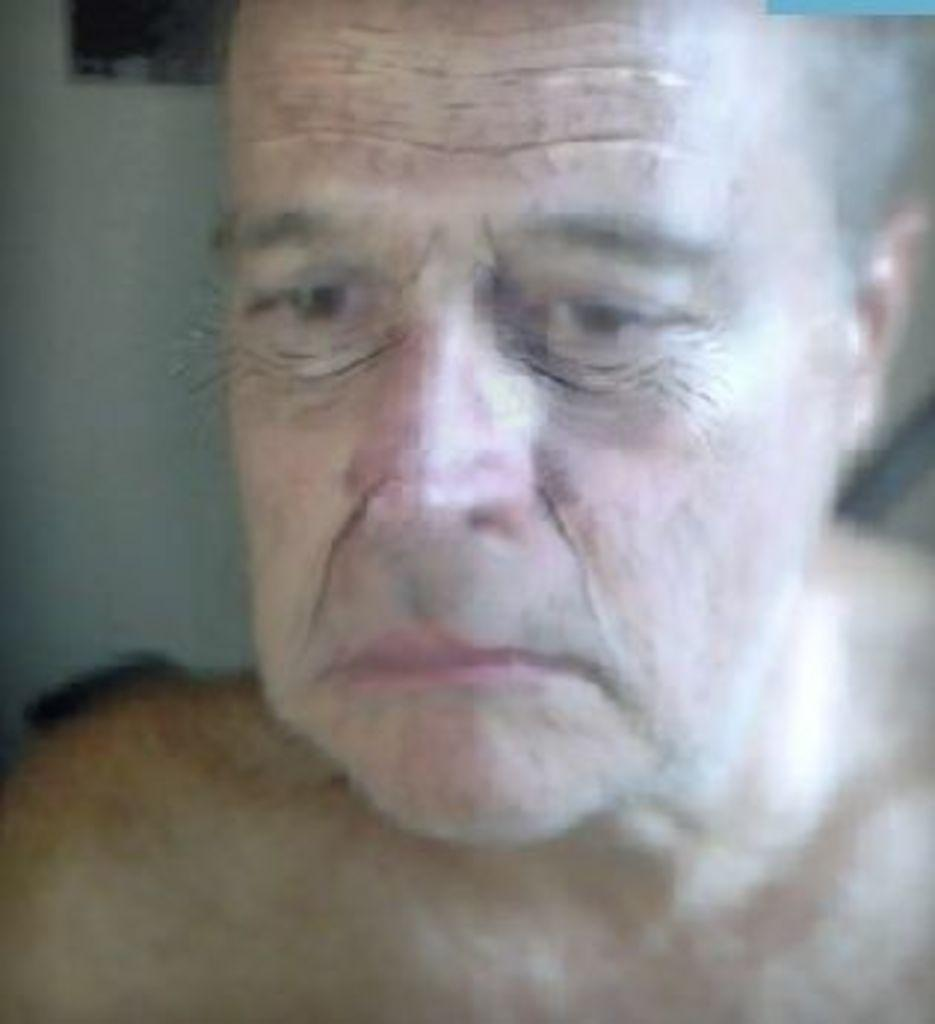Who is the main subject in the image? There is an old man in the image. What can be seen on the old man's face in the image? The old man's face is visible in the image. How many chairs are visible in the image? There is no mention of chairs in the provided facts, so we cannot determine the number of chairs in the image. 